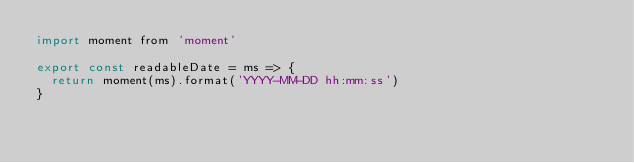<code> <loc_0><loc_0><loc_500><loc_500><_JavaScript_>import moment from 'moment'

export const readableDate = ms => {
  return moment(ms).format('YYYY-MM-DD hh:mm:ss')
}
</code> 